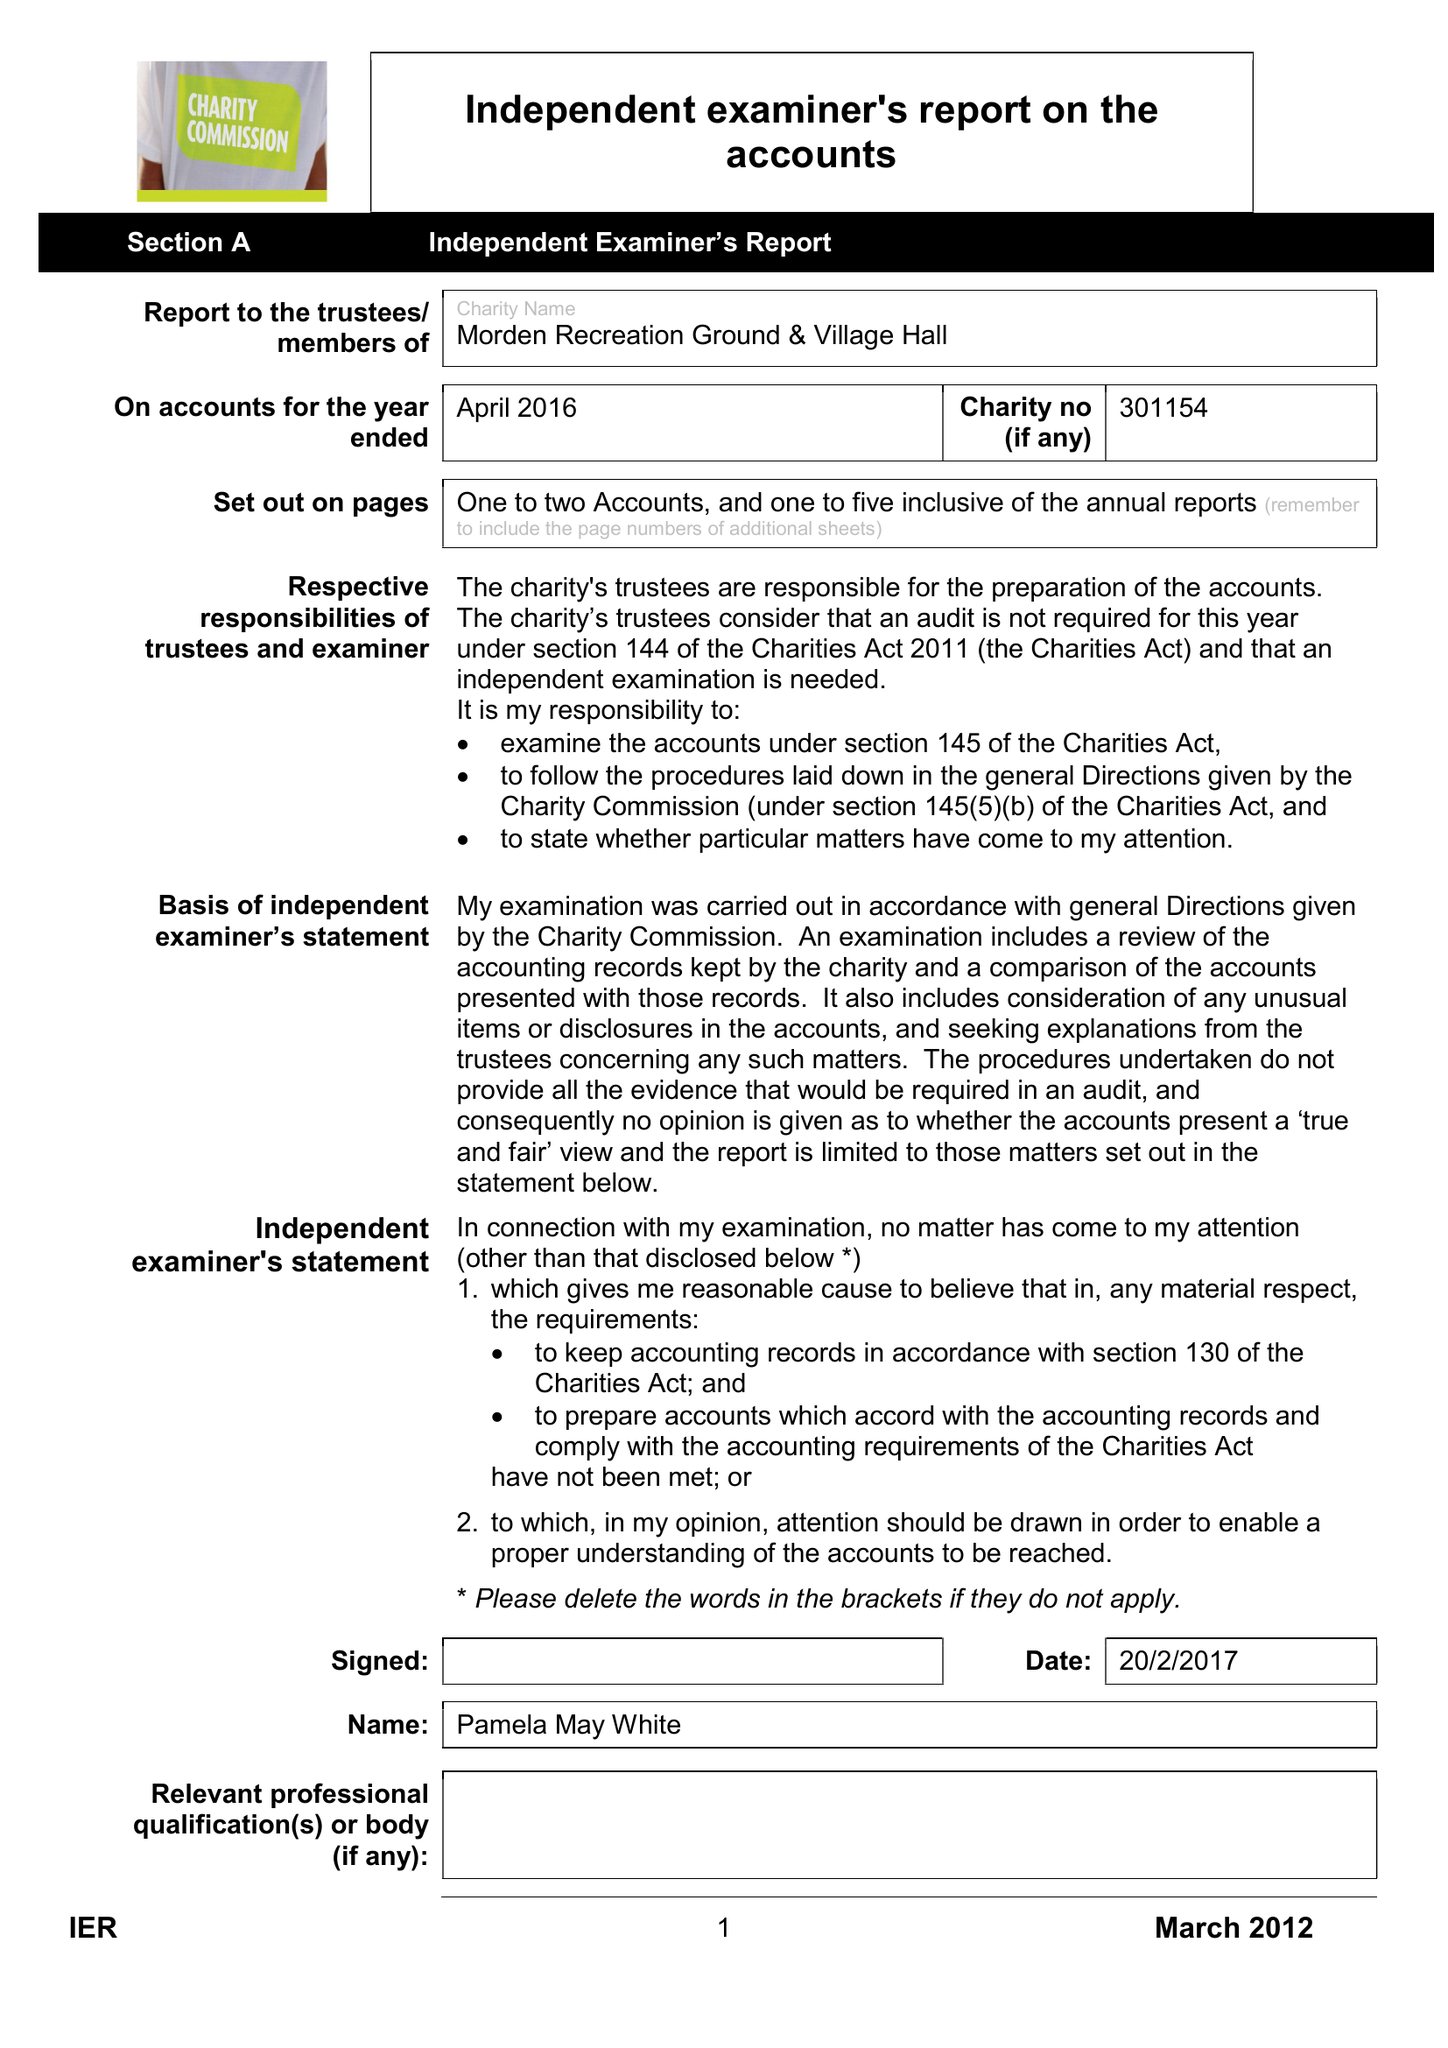What is the value for the charity_number?
Answer the question using a single word or phrase. 301154 